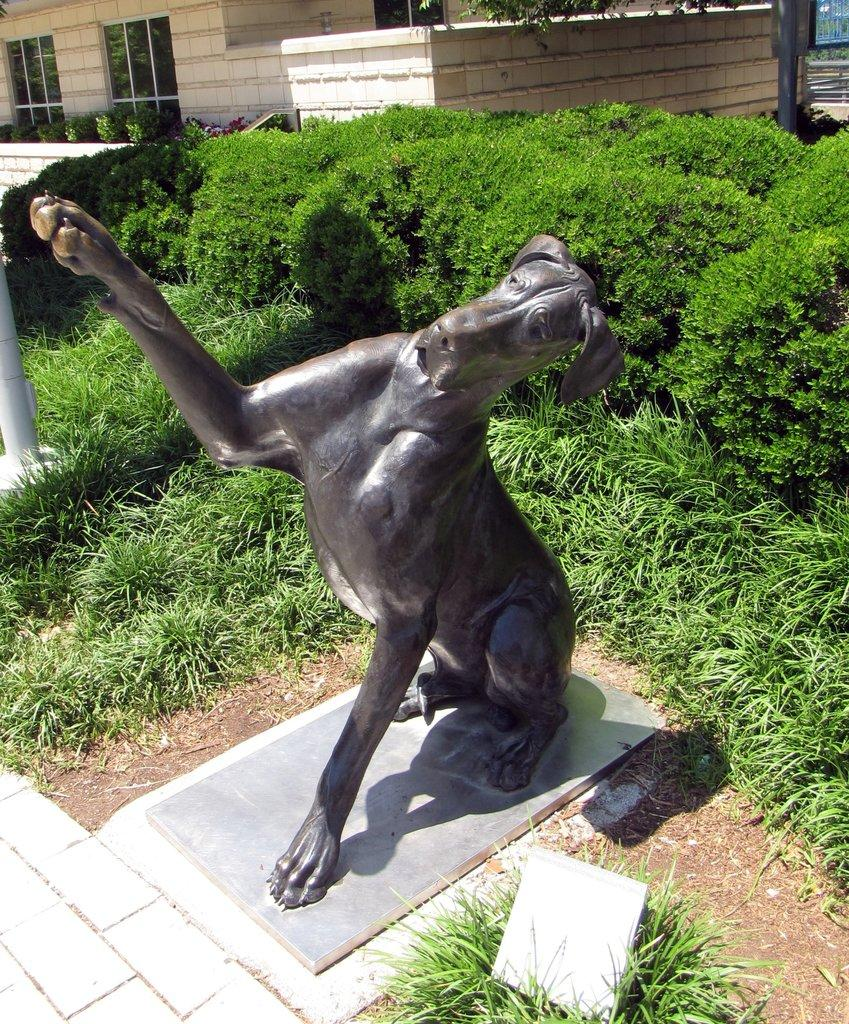What is the main subject of the statue in the image? There is a statue of an animal in the image. What type of vegetation is present behind the statue? There are plants behind the statue. What architectural features can be seen in the image? There are poles and a wall visible in the image. What type of structure might the image depict? The image appears to depict a house. How many brothers are depicted in the image? There are no people, let alone brothers, present in the image. The main subject is a statue of an animal. 